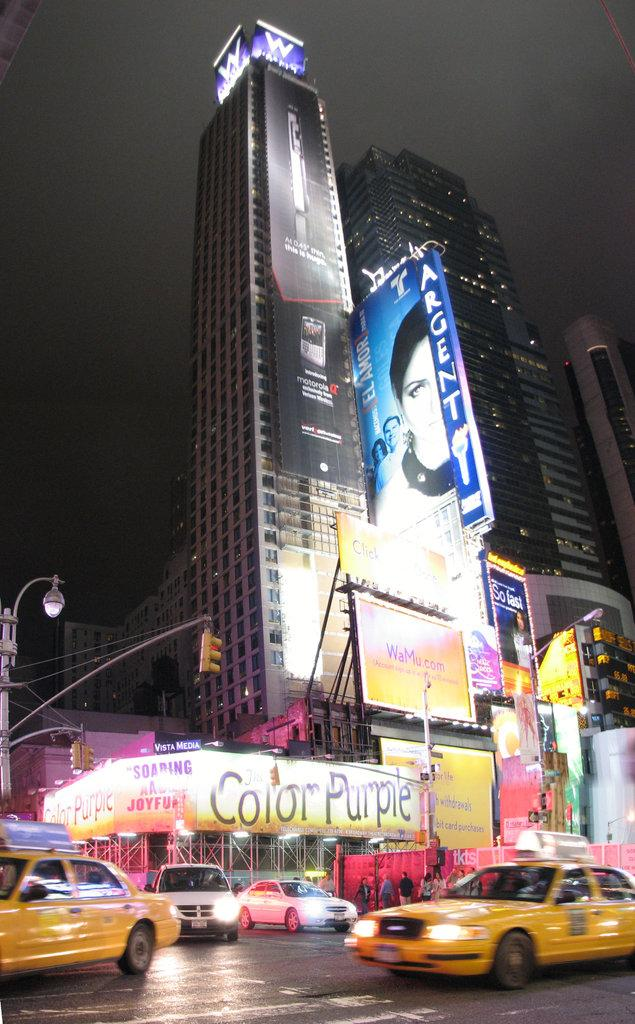<image>
Present a compact description of the photo's key features. Two taxi in the street in front of a building with Color Purple on top. 